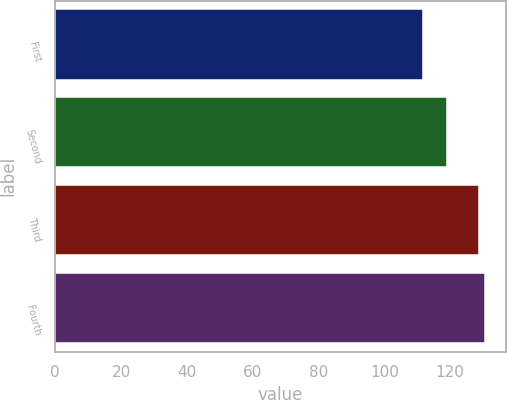Convert chart to OTSL. <chart><loc_0><loc_0><loc_500><loc_500><bar_chart><fcel>First<fcel>Second<fcel>Third<fcel>Fourth<nl><fcel>111.78<fcel>119.04<fcel>128.62<fcel>130.46<nl></chart> 